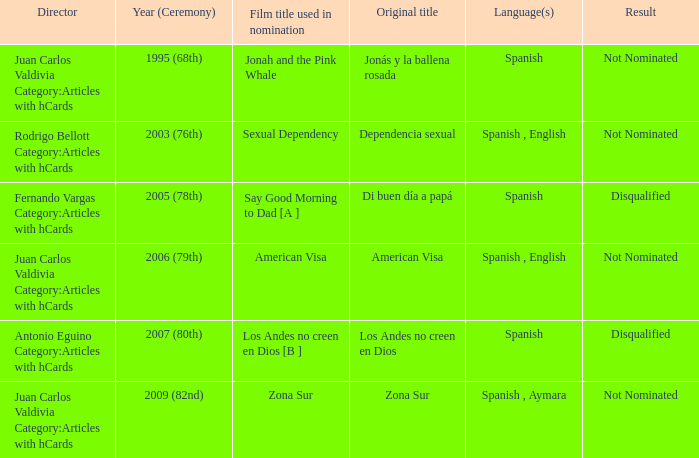What is Dependencia Sexual's film title that was used in its nomination? Sexual Dependency. 